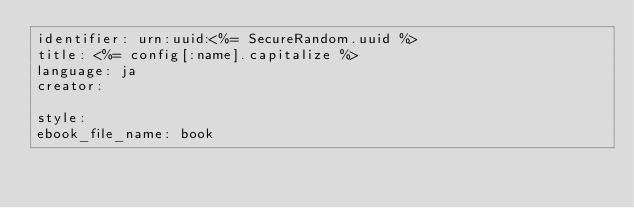<code> <loc_0><loc_0><loc_500><loc_500><_YAML_>identifier: urn:uuid:<%= SecureRandom.uuid %>
title: <%= config[:name].capitalize %>
language: ja
creator:

style:
ebook_file_name: book
</code> 